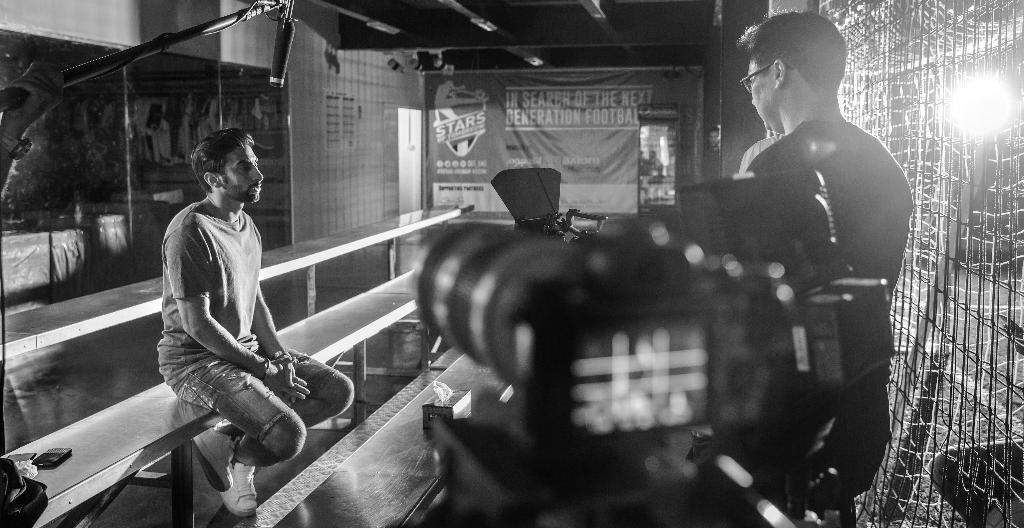Could you give a brief overview of what you see in this image? In this image we can see a person standing beside the fence. We can also see a camera and a light beside him. On the left side we can see a person sitting on the stairs containing a cellphone, tissue papers with a box and a bag. On the backside we can see a board and a roof. 